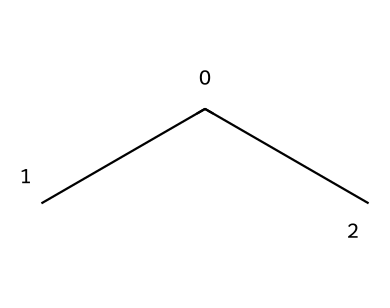What is the main repeating unit in polyethylene? The repeating unit in polyethylene is derived from the SMILES representation, which indicates that the polymer consists of ethylene (C(C)C) units.
Answer: ethylene How many carbon atoms are present in the structure? The SMILES representation shows two carbon atoms (C) in the main chain and denotes a branched structure, confirming the presence of three carbon atoms in total.
Answer: three What type of polymer is polyethylene classified as? Polyethylene is classified as a thermoplastic polymer, as indicated by its chemical structure that allows it to be molded and reformed upon heating.
Answer: thermoplastic What does the branching in this structure imply about its properties? The branched structure often leads to lower density and higher flexibility than linear polyethylene, affecting its use in applications like sports equipment padding.
Answer: flexibility What property makes polyethylene suitable for sports equipment padding? The presence of repeating ethylene units and its chemical structure contribute to its impact resistance and cushioning properties, making it ideal for padding in sports equipment.
Answer: impact resistance 